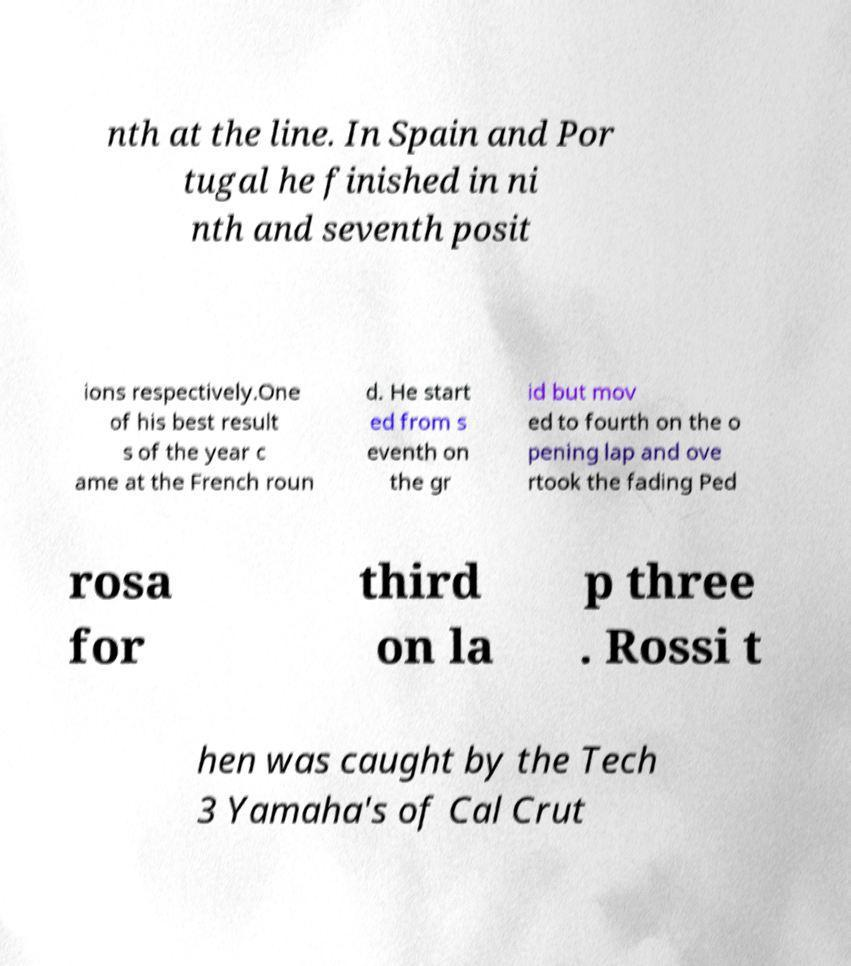Please read and relay the text visible in this image. What does it say? nth at the line. In Spain and Por tugal he finished in ni nth and seventh posit ions respectively.One of his best result s of the year c ame at the French roun d. He start ed from s eventh on the gr id but mov ed to fourth on the o pening lap and ove rtook the fading Ped rosa for third on la p three . Rossi t hen was caught by the Tech 3 Yamaha's of Cal Crut 